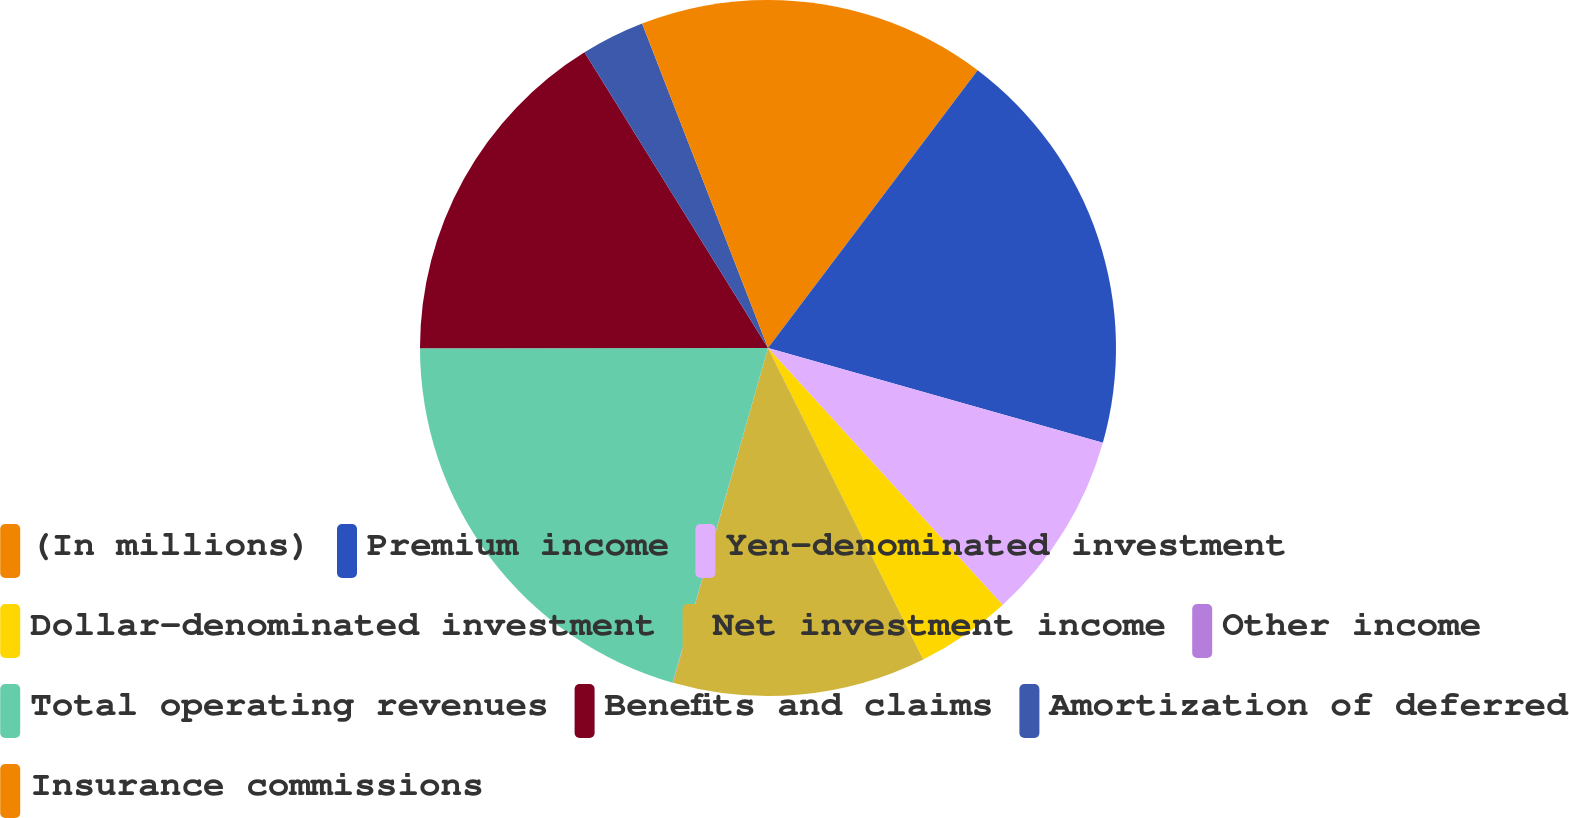Convert chart to OTSL. <chart><loc_0><loc_0><loc_500><loc_500><pie_chart><fcel>(In millions)<fcel>Premium income<fcel>Yen-denominated investment<fcel>Dollar-denominated investment<fcel>Net investment income<fcel>Other income<fcel>Total operating revenues<fcel>Benefits and claims<fcel>Amortization of deferred<fcel>Insurance commissions<nl><fcel>10.29%<fcel>19.1%<fcel>8.83%<fcel>4.42%<fcel>11.76%<fcel>0.02%<fcel>20.57%<fcel>16.17%<fcel>2.95%<fcel>5.89%<nl></chart> 